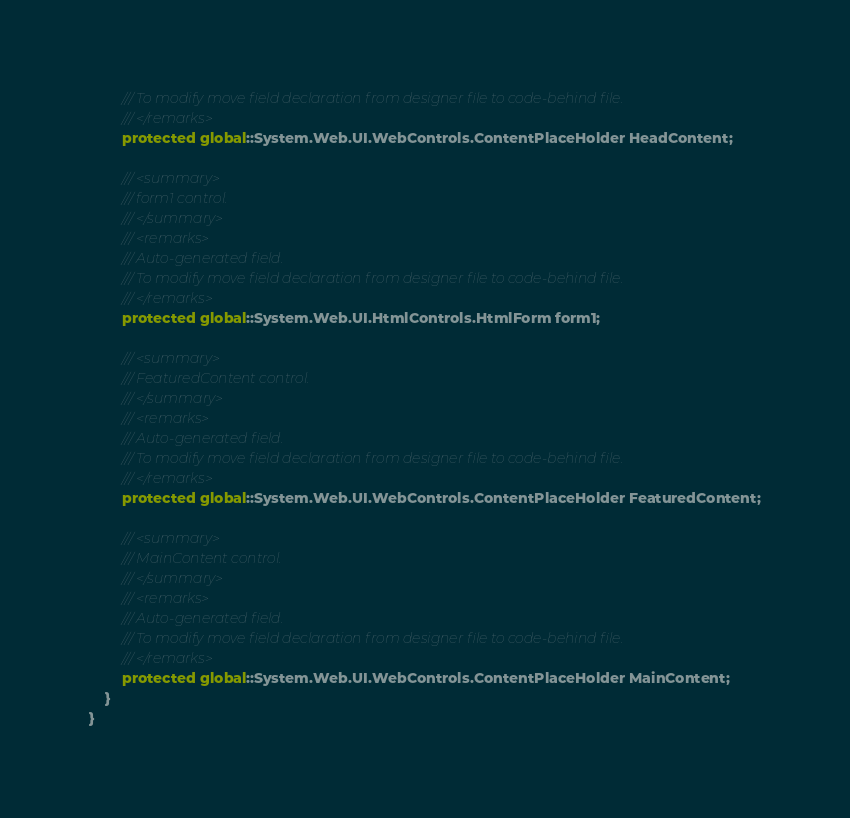Convert code to text. <code><loc_0><loc_0><loc_500><loc_500><_C#_>        /// To modify move field declaration from designer file to code-behind file.
        /// </remarks>
        protected global::System.Web.UI.WebControls.ContentPlaceHolder HeadContent;
        
        /// <summary>
        /// form1 control.
        /// </summary>
        /// <remarks>
        /// Auto-generated field.
        /// To modify move field declaration from designer file to code-behind file.
        /// </remarks>
        protected global::System.Web.UI.HtmlControls.HtmlForm form1;
        
        /// <summary>
        /// FeaturedContent control.
        /// </summary>
        /// <remarks>
        /// Auto-generated field.
        /// To modify move field declaration from designer file to code-behind file.
        /// </remarks>
        protected global::System.Web.UI.WebControls.ContentPlaceHolder FeaturedContent;
        
        /// <summary>
        /// MainContent control.
        /// </summary>
        /// <remarks>
        /// Auto-generated field.
        /// To modify move field declaration from designer file to code-behind file.
        /// </remarks>
        protected global::System.Web.UI.WebControls.ContentPlaceHolder MainContent;
    }
}
</code> 